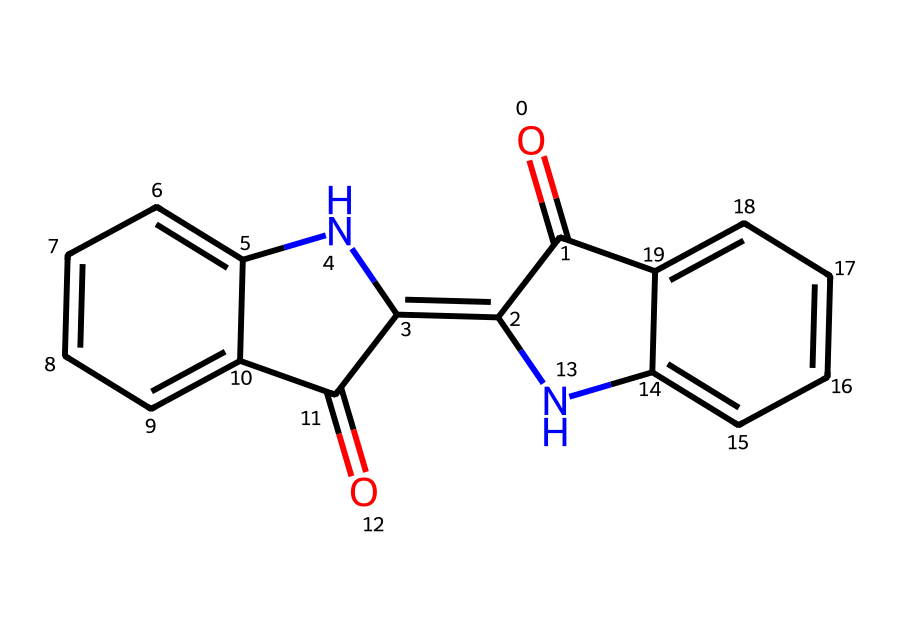What is the primary color produced by woad dye? The visual structure of the woad molecule indicates that it produces blue shades, which is a characteristic property of this plant dye.
Answer: blue How many nitrogen atoms are present in the woad dye structure? By examining the SMILES representation, we can identify two nitrogen atoms (N) present in the molecular structure.
Answer: 2 What type of chemical compound is woad classified as? Woad is classified as a natural dye due to its origin from plants and its application in coloring fabrics, especially before synthetic dyes were developed.
Answer: natural dye What is the molecular formula of woad? The molecular structure corresponds to the chemical formula C15H12N2O2, which can be derived by counting each atom through the structure provided in the SMILES notation.
Answer: C15H12N2O2 How many rings are present in the woad molecular structure? By analyzing the structure, we can see that there are four interconnected rings in the woad molecule, which is a common characteristic among many dyes.
Answer: 4 What does the presence of nitrogen indicate about woad? The presence of nitrogen typically suggests that the compound may exhibit properties such as being an alkaloid or having biological activity, especially in the context of plant-based compounds.
Answer: biological activity How many double bonds can be found in the woad structure? Upon detailed examination of the structure, there are a total of four double bonds indicated in the molecular framework of woad, which contributes to its reactivity and color properties.
Answer: 4 